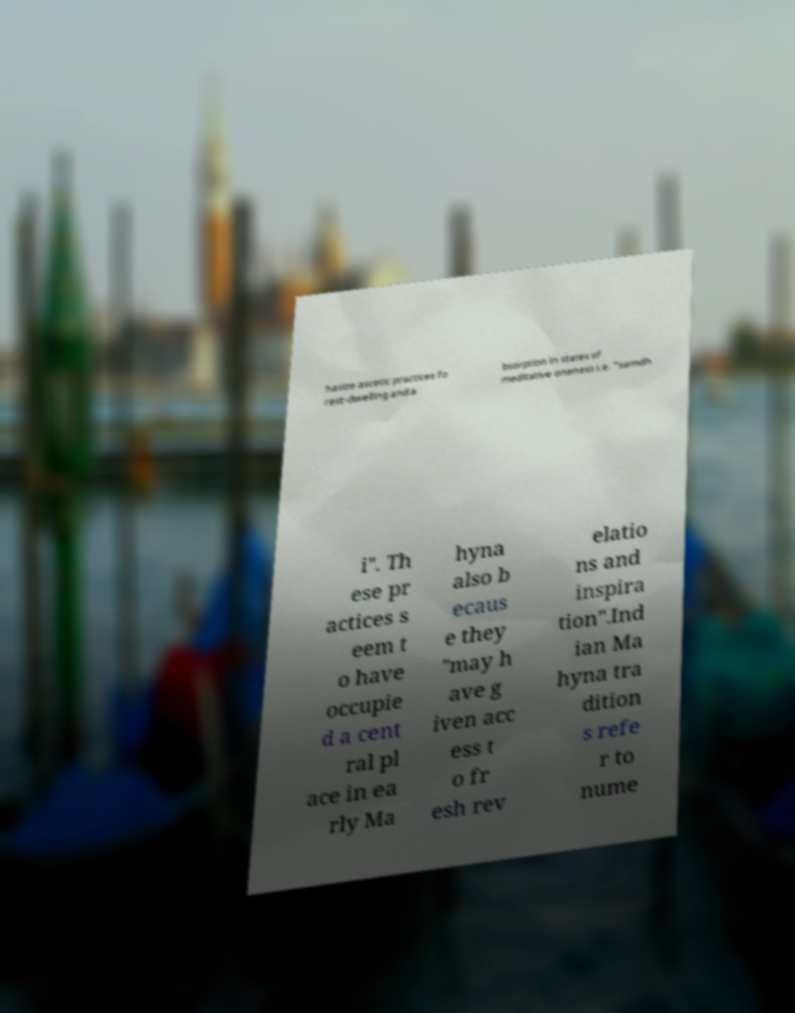What messages or text are displayed in this image? I need them in a readable, typed format. hasize ascetic practices fo rest-dwelling and a bsorption in states of meditative oneness i.e. "samdh i". Th ese pr actices s eem t o have occupie d a cent ral pl ace in ea rly Ma hyna also b ecaus e they "may h ave g iven acc ess t o fr esh rev elatio ns and inspira tion".Ind ian Ma hyna tra dition s refe r to nume 